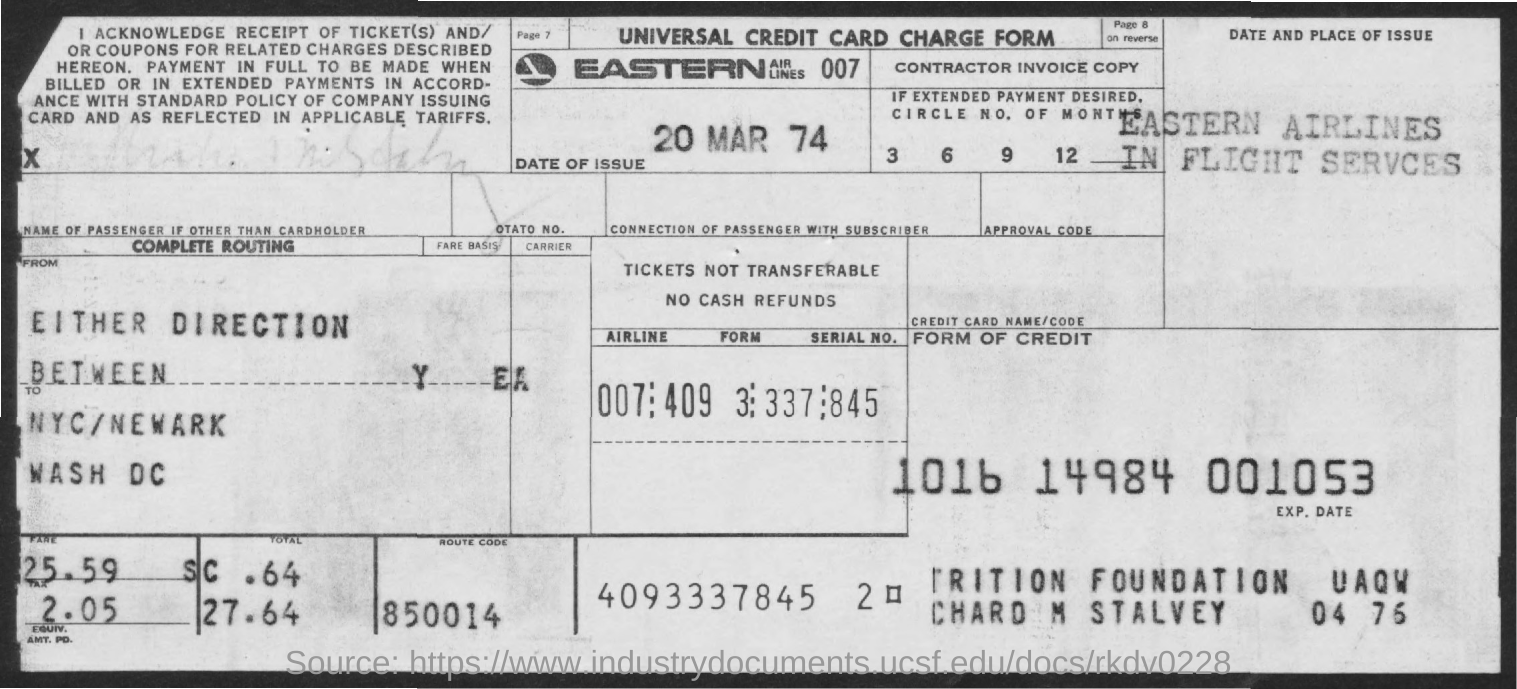Identify some key points in this picture. The date of issue mentioned in the given form is March 20, 1974. What is the route code mentioned in the given form?" is a question asking for information. The route code is the code for a specific route in the form. 